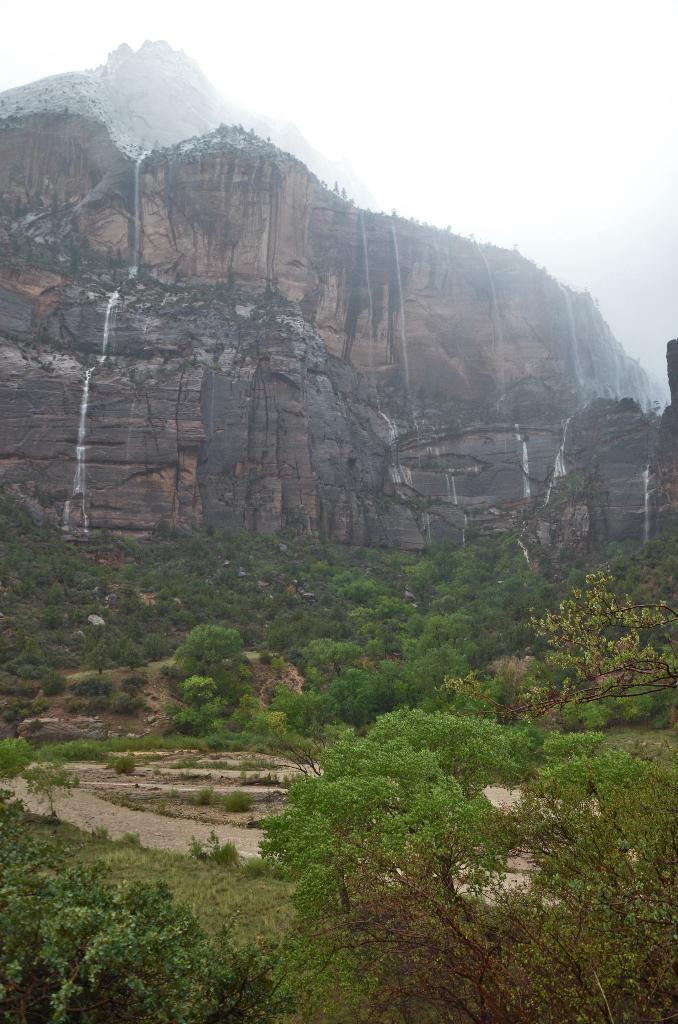What type of vegetation is at the bottom of the image? There are trees at the bottom of the image. What geographical feature can be seen in the image? There is a hill in the image. How would you describe the overall appearance of the image? The image appears to be foggy. What type of stage can be seen in the image? There is no stage present in the image; it features trees and a hill. Can you tell me how many beetles are crawling on the hill in the image? There are no beetles present in the image; it features trees and a hill. 